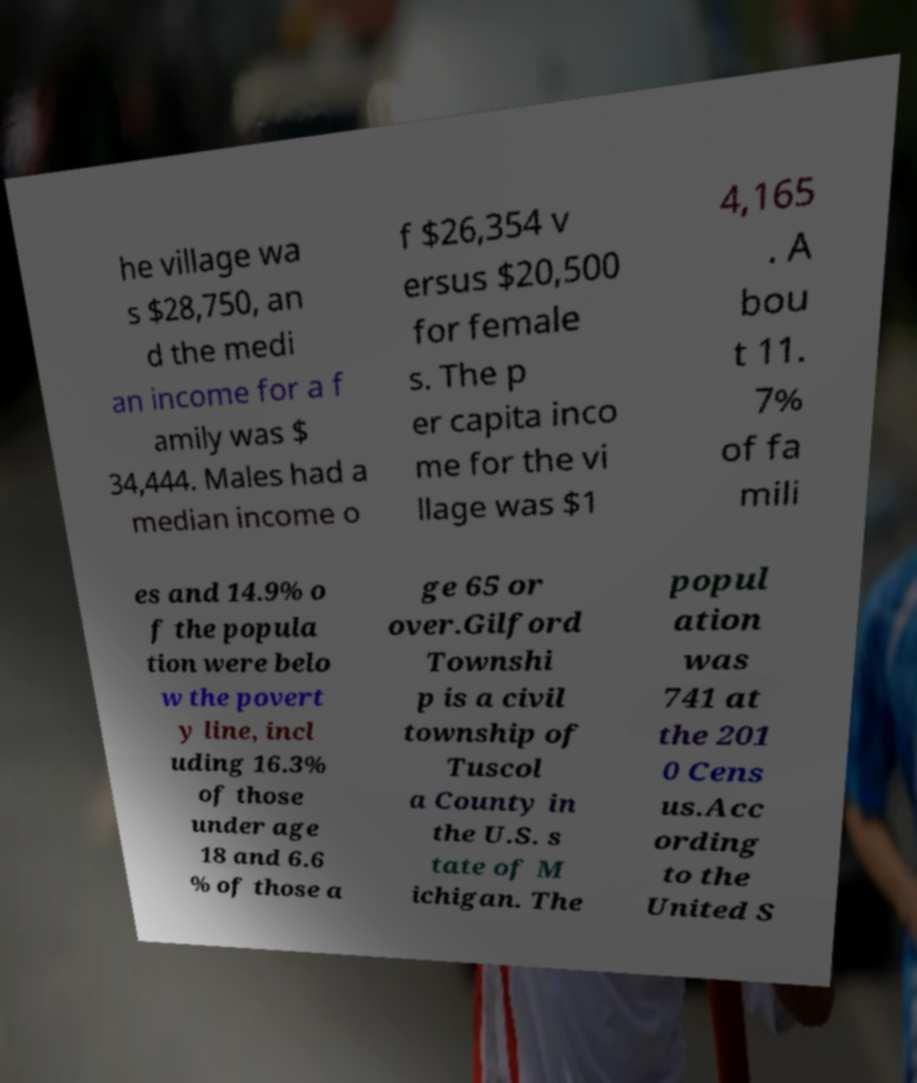Please identify and transcribe the text found in this image. he village wa s $28,750, an d the medi an income for a f amily was $ 34,444. Males had a median income o f $26,354 v ersus $20,500 for female s. The p er capita inco me for the vi llage was $1 4,165 . A bou t 11. 7% of fa mili es and 14.9% o f the popula tion were belo w the povert y line, incl uding 16.3% of those under age 18 and 6.6 % of those a ge 65 or over.Gilford Townshi p is a civil township of Tuscol a County in the U.S. s tate of M ichigan. The popul ation was 741 at the 201 0 Cens us.Acc ording to the United S 